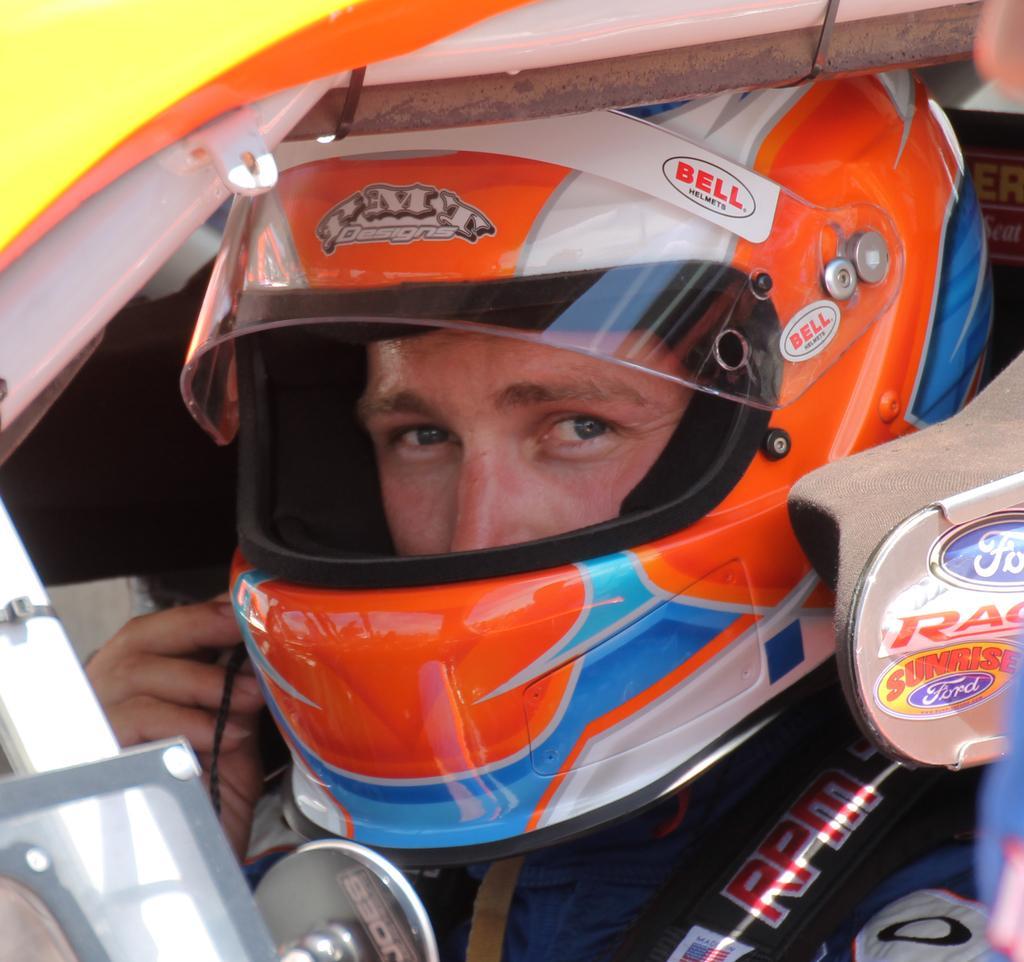Describe this image in one or two sentences. In this image I can see a person wearing a helmet visible in the foreground. 